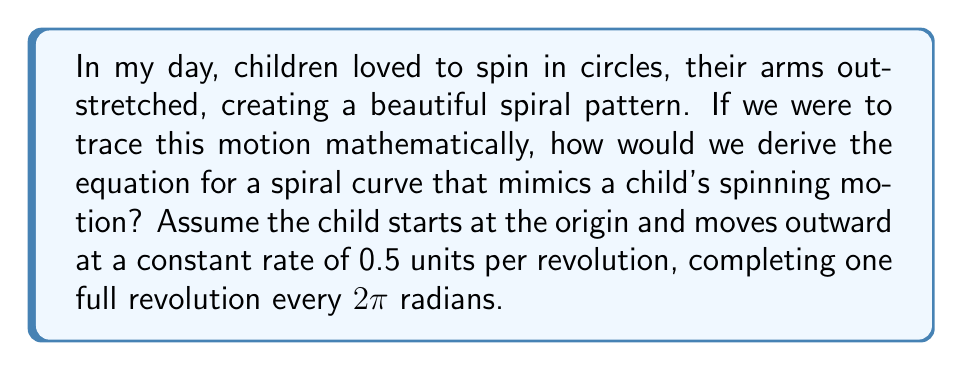Give your solution to this math problem. Let's approach this step-by-step:

1) First, we need to understand that this type of spiral is known as an Archimedean spiral. In polar coordinates, it has the general form:

   $$r = a + b\theta$$

   where $r$ is the distance from the origin, $\theta$ is the angle in radians, $a$ is the starting radius, and $b$ is the rate at which the spiral moves outward.

2) In our case, the child starts at the origin, so $a = 0$.

3) The child moves outward at 0.5 units per revolution. One revolution is 2π radians, so:

   $$b = \frac{0.5}{2\pi} = \frac{1}{4\pi}$$

4) Substituting these values into our general equation:

   $$r = \frac{1}{4\pi}\theta$$

5) To convert this to Cartesian coordinates, we use the following relationships:

   $$x = r \cos(\theta)$$
   $$y = r \sin(\theta)$$

6) Substituting our equation for $r$:

   $$x = \frac{1}{4\pi}\theta \cos(\theta)$$
   $$y = \frac{1}{4\pi}\theta \sin(\theta)$$

7) These parametric equations describe the spiral curve that mimics the child's spinning motion.
Answer: $x = \frac{1}{4\pi}\theta \cos(\theta)$, $y = \frac{1}{4\pi}\theta \sin(\theta)$ 